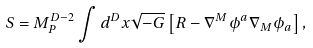Convert formula to latex. <formula><loc_0><loc_0><loc_500><loc_500>S = M _ { P } ^ { D - 2 } \int d ^ { D } x \sqrt { - G } \left [ R - \nabla ^ { M } \phi ^ { a } \nabla _ { M } \phi _ { a } \right ] ,</formula> 